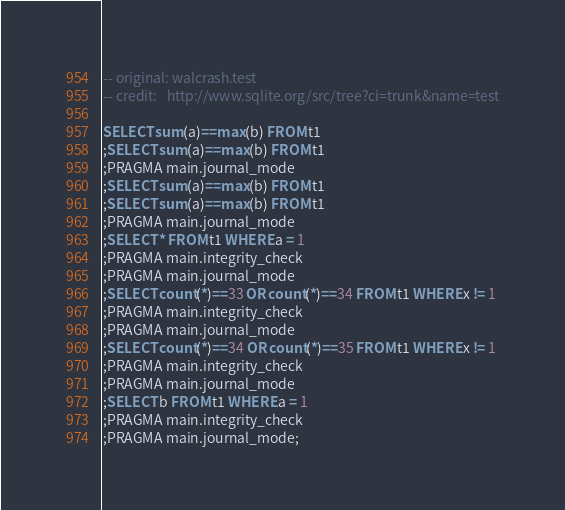<code> <loc_0><loc_0><loc_500><loc_500><_SQL_>-- original: walcrash.test
-- credit:   http://www.sqlite.org/src/tree?ci=trunk&name=test

SELECT sum(a)==max(b) FROM t1
;SELECT sum(a)==max(b) FROM t1
;PRAGMA main.journal_mode
;SELECT sum(a)==max(b) FROM t1
;SELECT sum(a)==max(b) FROM t1
;PRAGMA main.journal_mode
;SELECT * FROM t1 WHERE a = 1
;PRAGMA main.integrity_check
;PRAGMA main.journal_mode
;SELECT count(*)==33 OR count(*)==34 FROM t1 WHERE x != 1
;PRAGMA main.integrity_check
;PRAGMA main.journal_mode
;SELECT count(*)==34 OR count(*)==35 FROM t1 WHERE x != 1
;PRAGMA main.integrity_check
;PRAGMA main.journal_mode
;SELECT b FROM t1 WHERE a = 1
;PRAGMA main.integrity_check
;PRAGMA main.journal_mode;</code> 